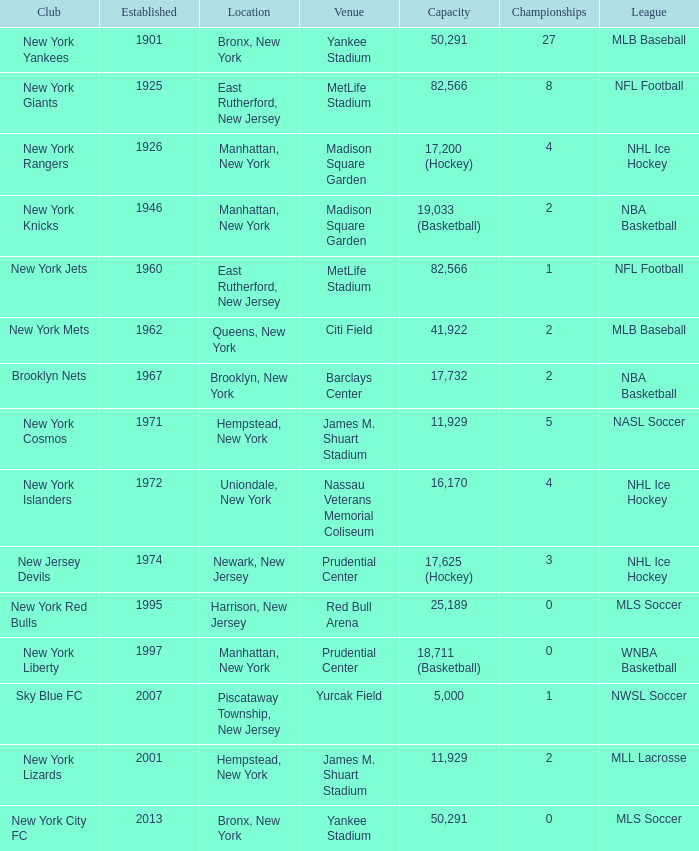When was the venue named nassau veterans memorial coliseum established?? 1972.0. 